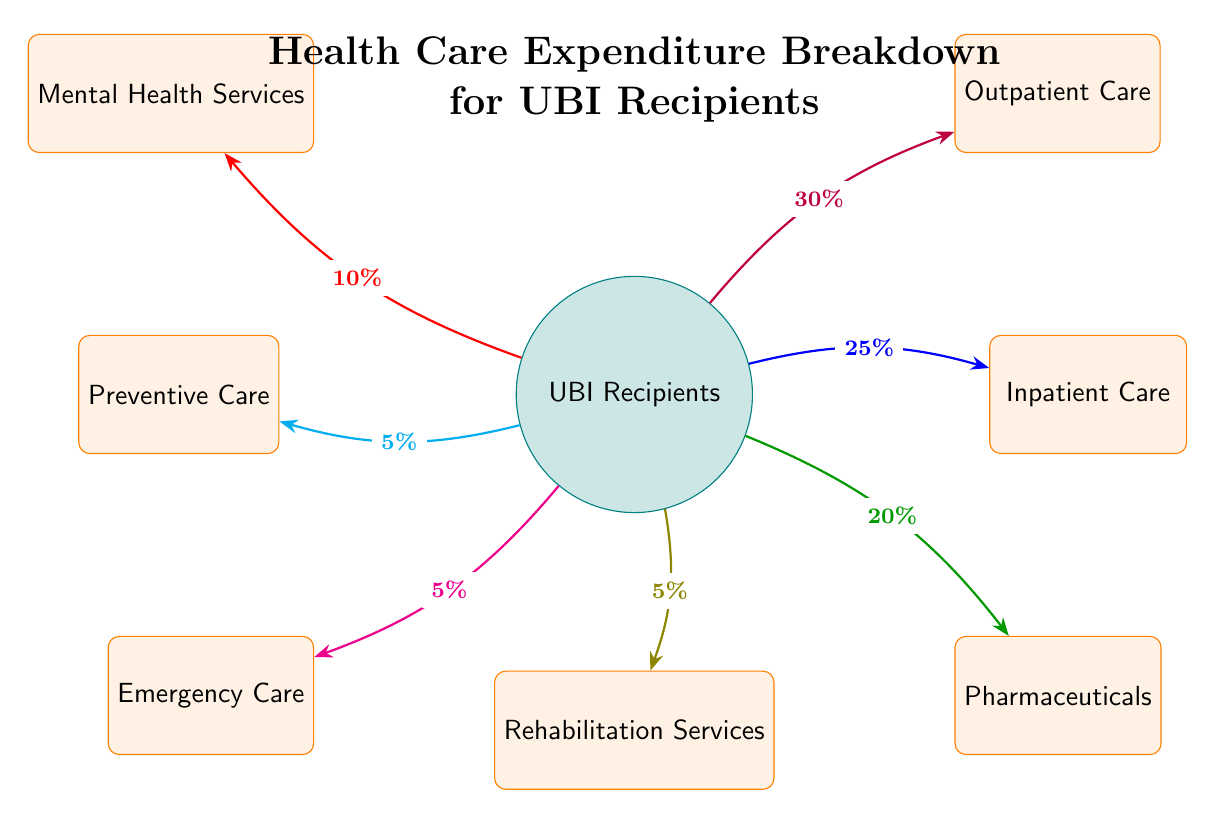What percentage of healthcare expenditure is allocated to outpatient care? The diagram shows a direct arrow from the UBI Recipients node to the Outpatient Care node labeled with the percentage. It indicates that 30% of healthcare expenditure is allocated to outpatient care.
Answer: 30% What is the least funded category in healthcare expenditures? By inspecting the percentages on the arrows leading from UBI Recipients, the category with the smallest percentage is the Preventive Care category, which has 5% allocated to it.
Answer: Preventive Care How many healthcare expenditure categories are shown in the diagram? The diagram displays a total of seven categories related to healthcare expenditure, which are listed clearly around the UBI Recipients node.
Answer: Seven What percentage of healthcare costs goes toward Mental Health Services and Rehabilitation Services combined? To find the combined percentage, add the respective percentages of Mental Health Services (10%) and Rehabilitation Services (5%). Thus, 10% + 5% equals 15%.
Answer: 15% Which category receives a higher share of healthcare expenditure: Inpatient Care or Pharmaceuticals? The percentages for Inpatient Care (25%) and Pharmaceuticals (20%) can be compared; Inpatient Care has a higher allocation of funds than Pharmaceuticals.
Answer: Inpatient Care What is the total percentage allocated to emergency and preventive care combined? Adding the percentages from Emergency Care (5%) and Preventive Care (5%) gives 5% + 5%, resulting in a total of 10%.
Answer: 10% What does the color of the arrows representing Outpatient Care indicate? The purple arrow leading to Outpatient Care suggests it is the most significant category in terms of percentage allocation among the healthcare expenditure categories shown in the diagram.
Answer: Purple In which direction do most arrows indicating healthcare expenditure flow? All arrows in the diagram flow from the center node "UBI Recipients" outward towards the various healthcare expenditure categories, indicating that all funds are allocated to these categories.
Answer: Outward 